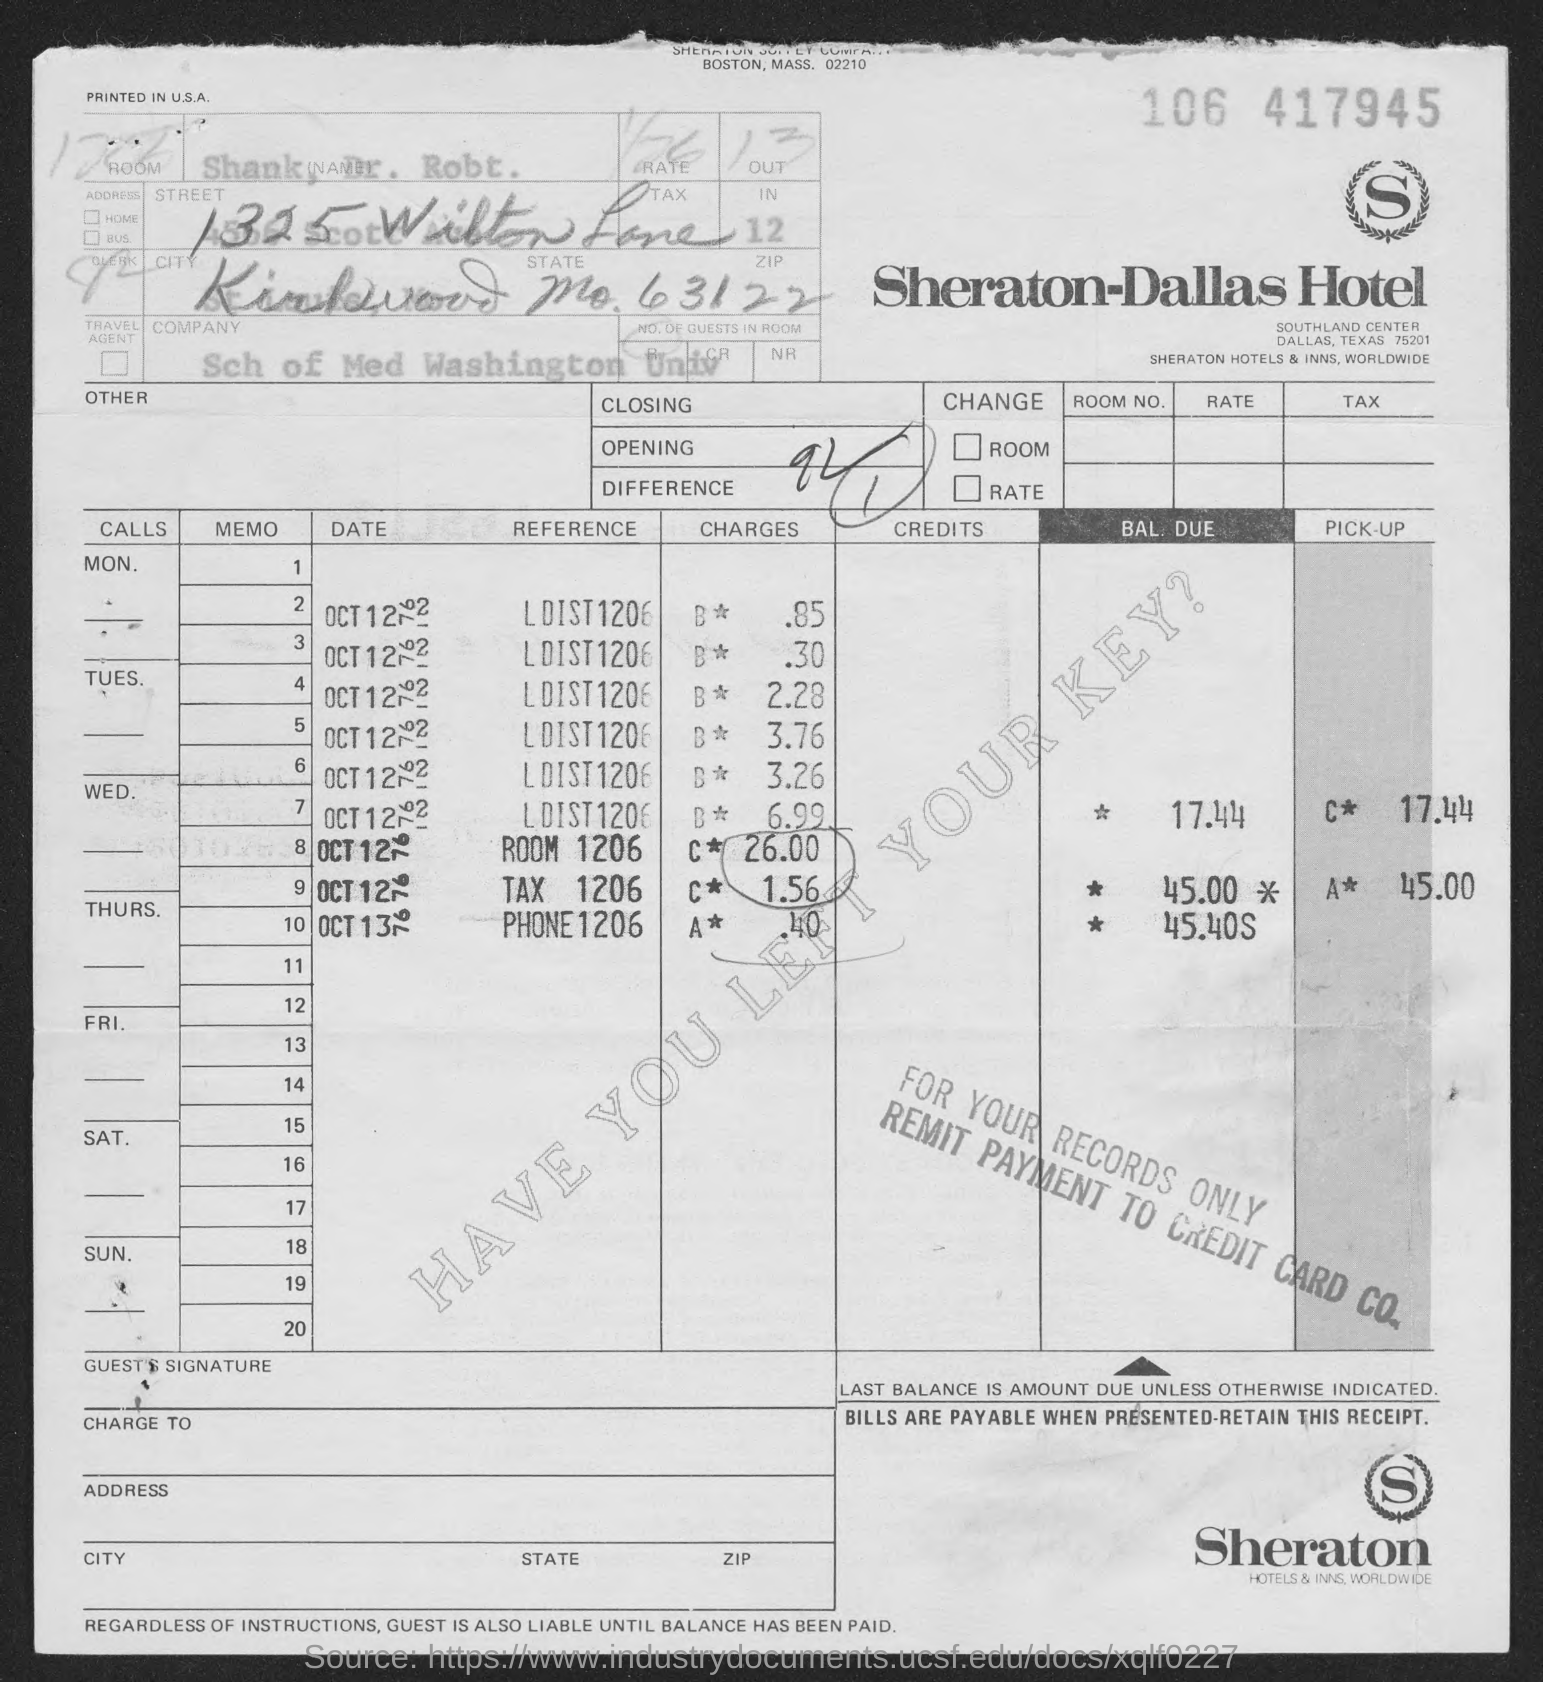Outline some significant characteristics in this image. The hotel bill for Sheraton-Dallas is provided. 